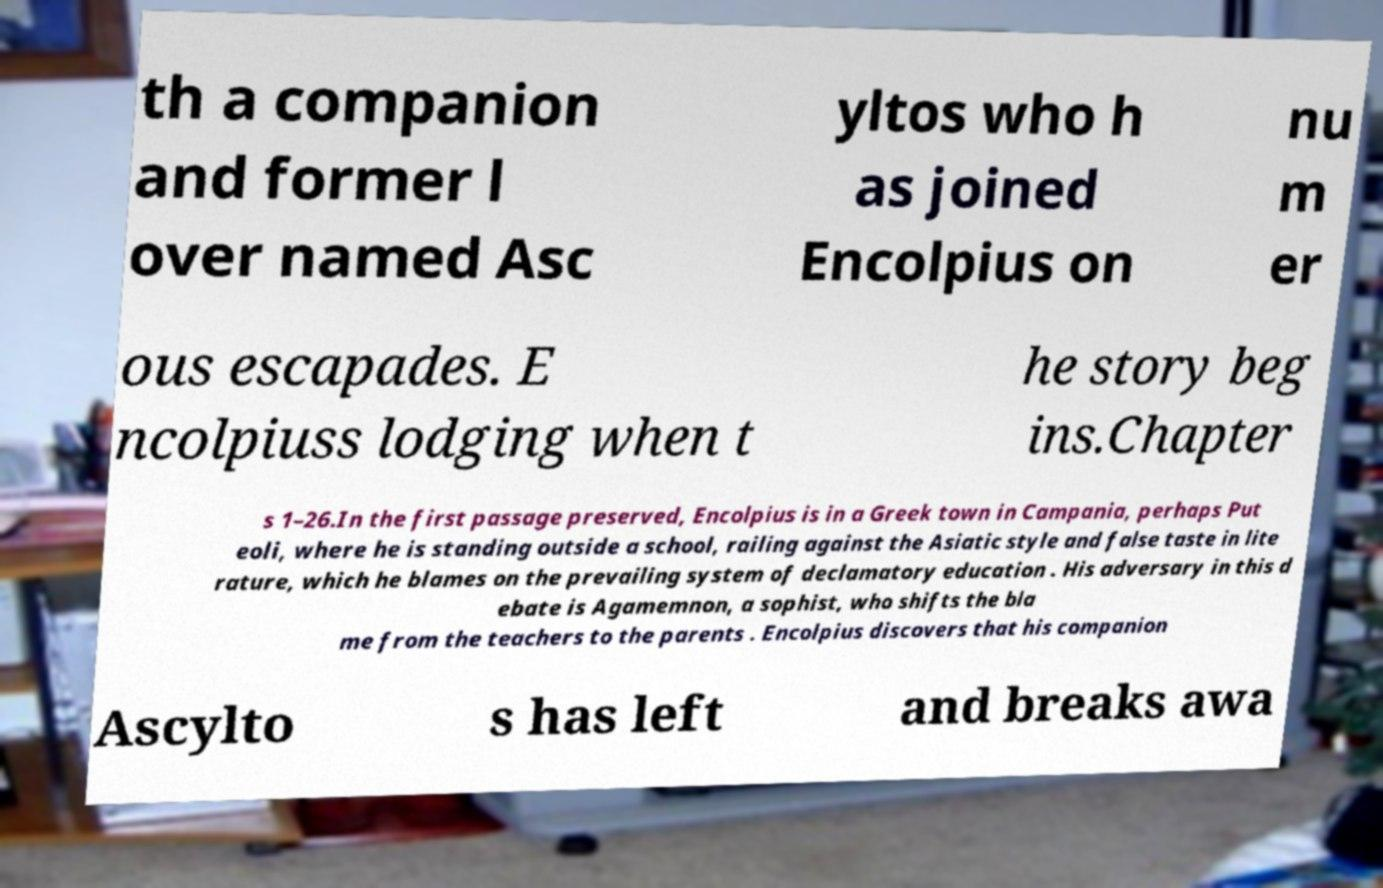Could you extract and type out the text from this image? th a companion and former l over named Asc yltos who h as joined Encolpius on nu m er ous escapades. E ncolpiuss lodging when t he story beg ins.Chapter s 1–26.In the first passage preserved, Encolpius is in a Greek town in Campania, perhaps Put eoli, where he is standing outside a school, railing against the Asiatic style and false taste in lite rature, which he blames on the prevailing system of declamatory education . His adversary in this d ebate is Agamemnon, a sophist, who shifts the bla me from the teachers to the parents . Encolpius discovers that his companion Ascylto s has left and breaks awa 